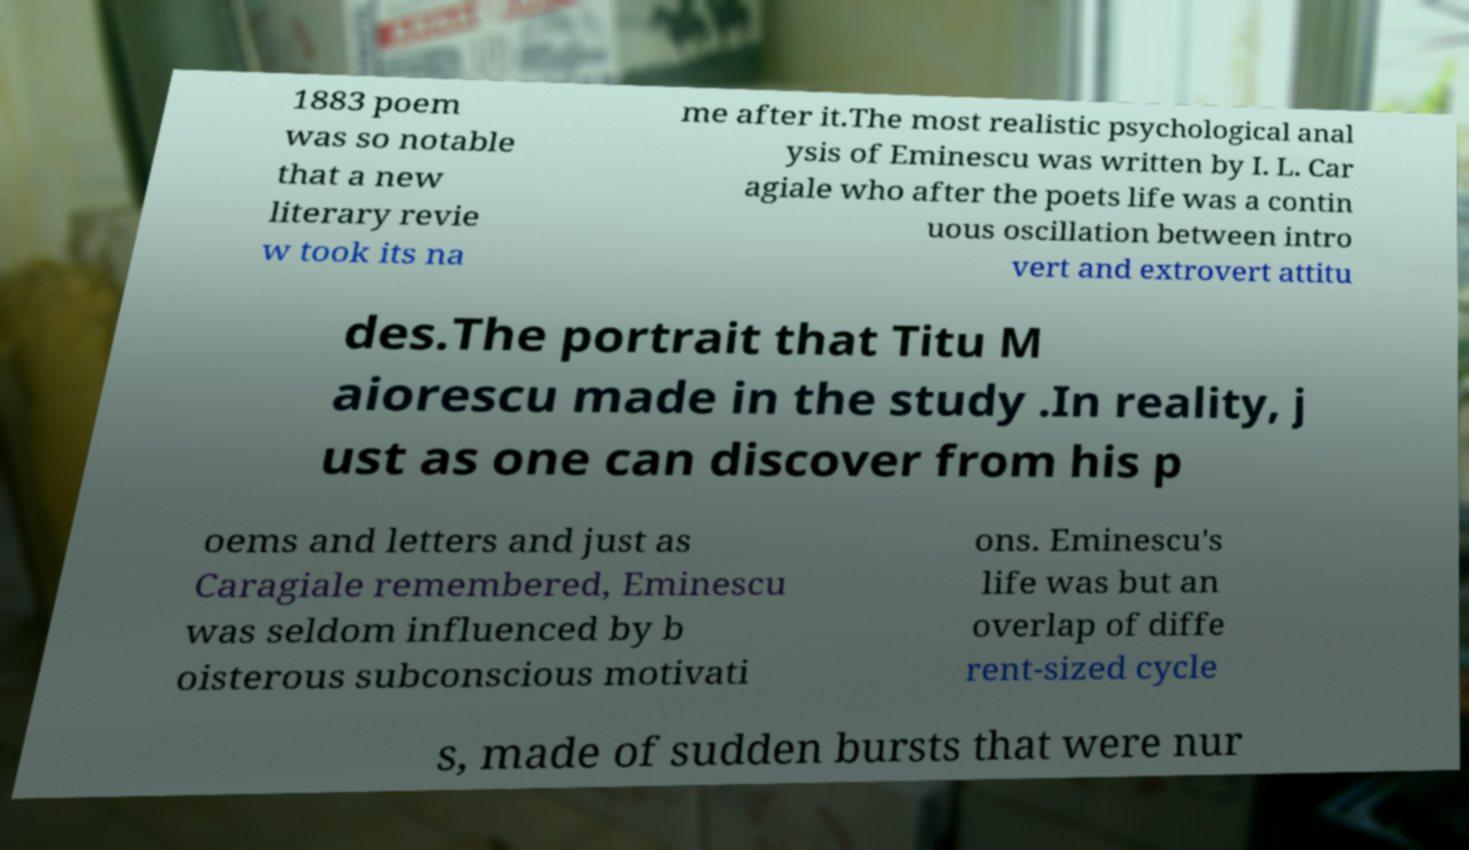I need the written content from this picture converted into text. Can you do that? 1883 poem was so notable that a new literary revie w took its na me after it.The most realistic psychological anal ysis of Eminescu was written by I. L. Car agiale who after the poets life was a contin uous oscillation between intro vert and extrovert attitu des.The portrait that Titu M aiorescu made in the study .In reality, j ust as one can discover from his p oems and letters and just as Caragiale remembered, Eminescu was seldom influenced by b oisterous subconscious motivati ons. Eminescu's life was but an overlap of diffe rent-sized cycle s, made of sudden bursts that were nur 